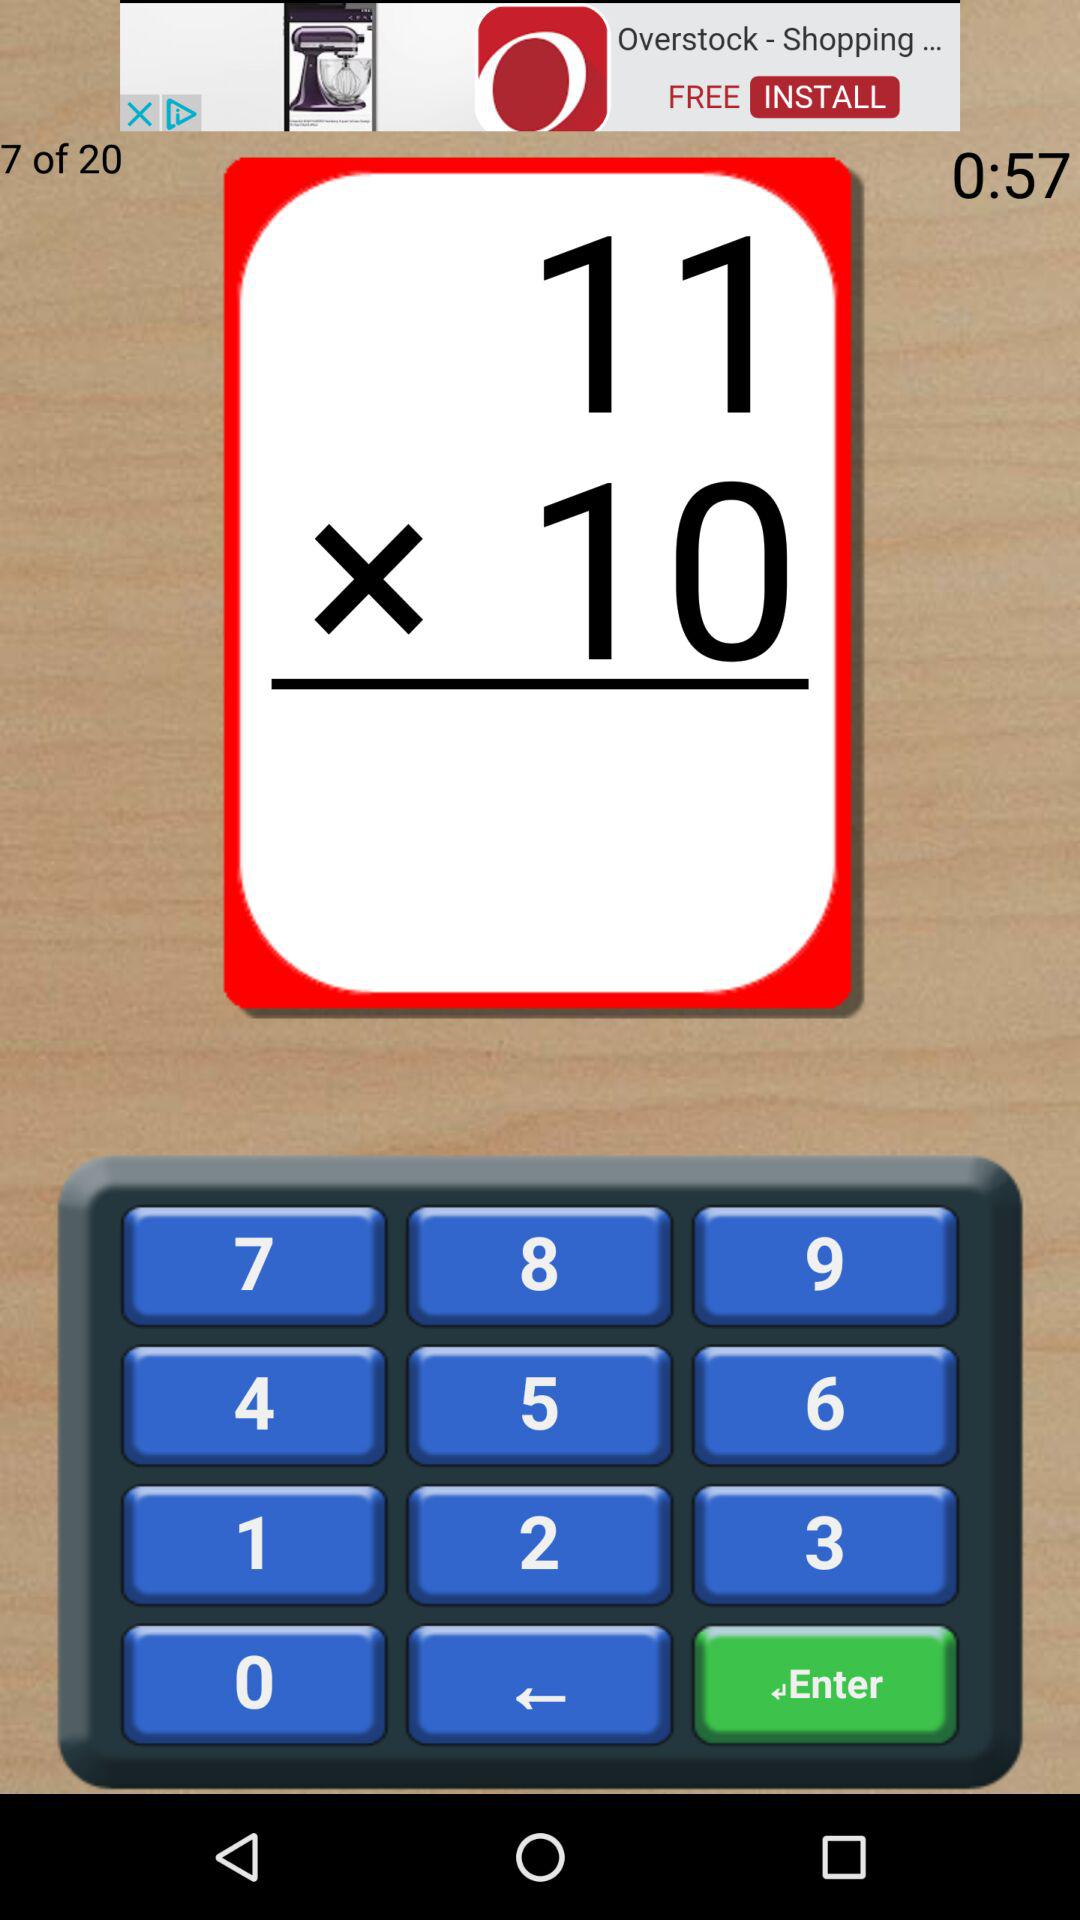How many seconds is the timer counting down?
Answer the question using a single word or phrase. 57 